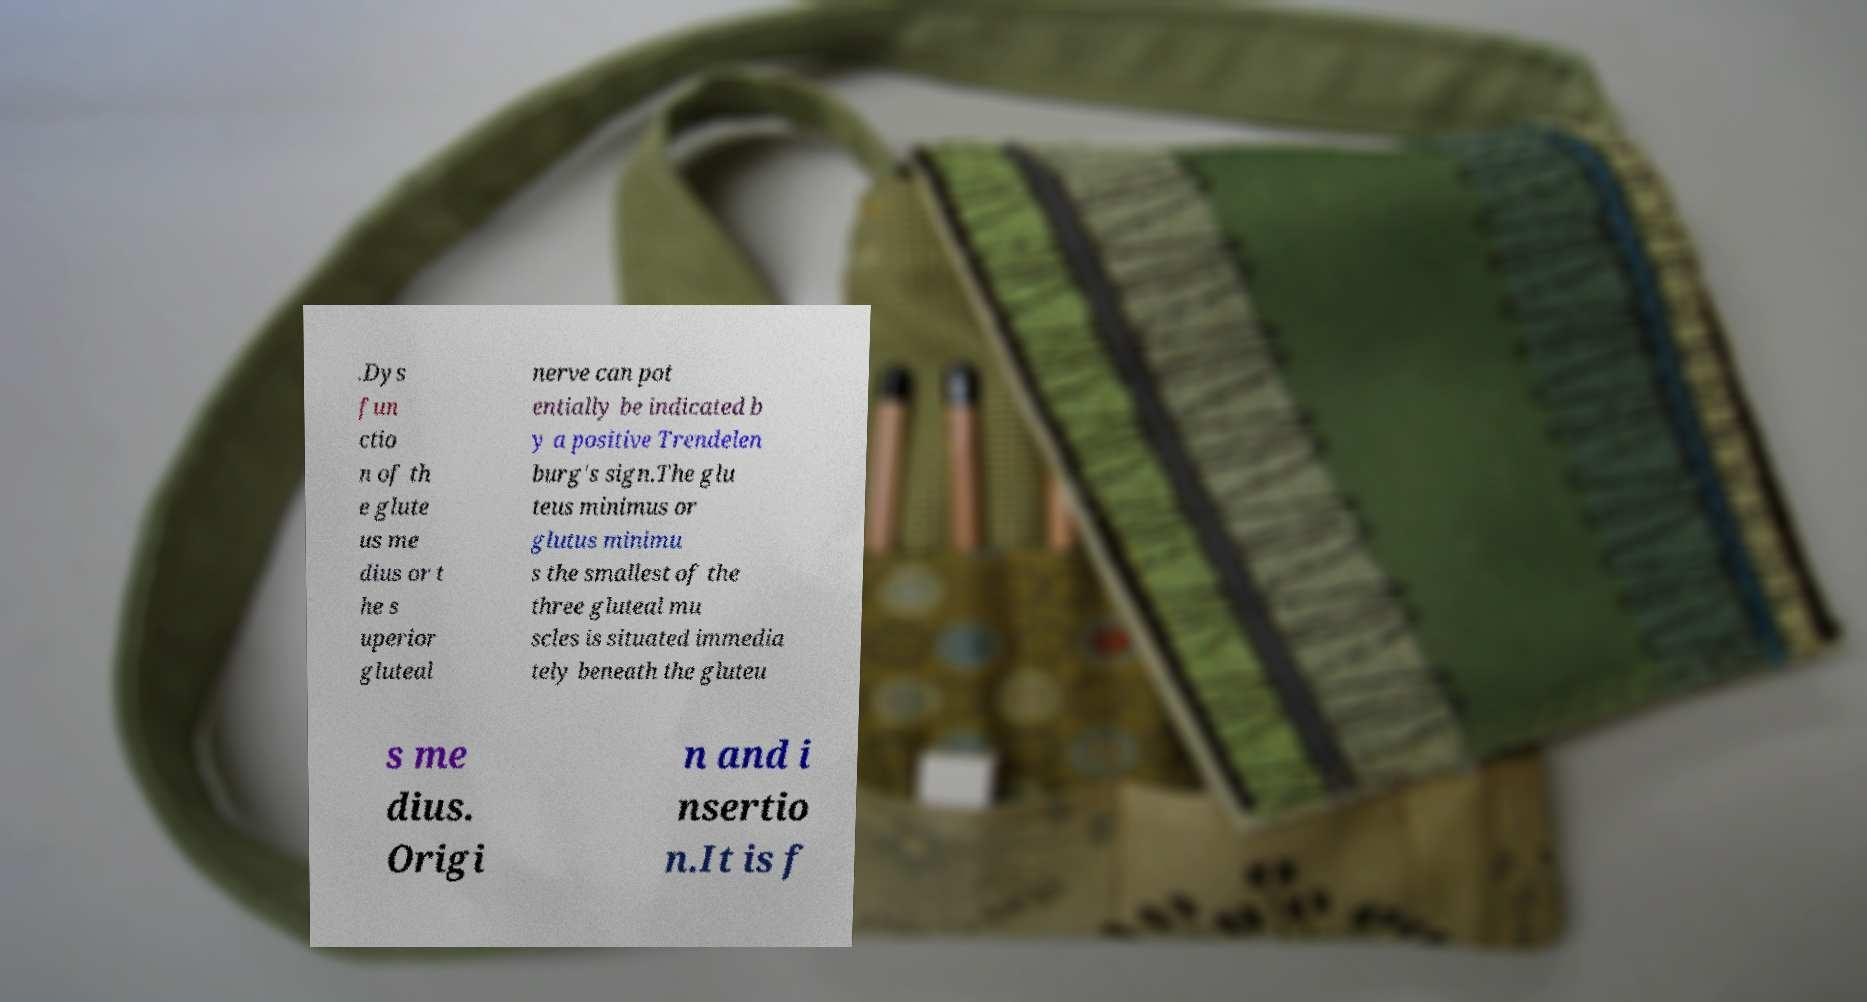I need the written content from this picture converted into text. Can you do that? .Dys fun ctio n of th e glute us me dius or t he s uperior gluteal nerve can pot entially be indicated b y a positive Trendelen burg's sign.The glu teus minimus or glutus minimu s the smallest of the three gluteal mu scles is situated immedia tely beneath the gluteu s me dius. Origi n and i nsertio n.It is f 